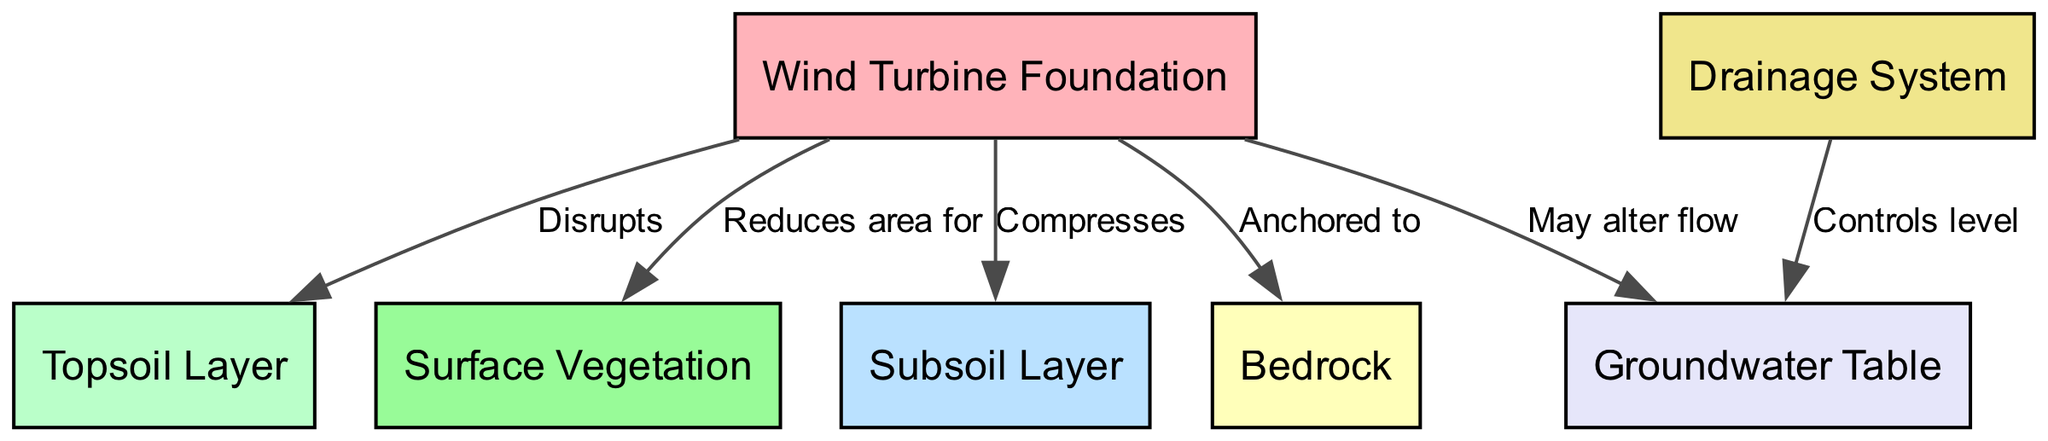What is the top layer above the wind turbine foundation? The diagram shows several layers of soil and structures in relation to the wind turbine foundation. The node directly above the foundation is identified as the "Topsoil Layer."
Answer: Topsoil Layer How many layers of soil are indicated in the diagram? The diagram includes three distinct layers of soil: Topsoil Layer, Subsoil Layer, and Bedrock. By counting these nodes, we find there are three layers.
Answer: Three What does the wind turbine foundation disrupt? According to the edge leading from the foundation to the topsoil, it is labeled "Disrupts," indicating the relationship between these two elements. Therefore, the foundation disrupts the Topsoil Layer.
Answer: Topsoil Layer Which layer is compressed by the wind turbine foundation? The diagram shows a direct connection between the foundation and the Subsoil Layer labeled "Compresses." This indicates that the wind turbine foundation compresses the subsoil.
Answer: Subsoil Layer What effect does the wind turbine foundation have on groundwater flow? The edge from the foundation to the groundwater indicates "May alter flow." This shows that the foundation can potentially change the flow of groundwater in the area.
Answer: May alter flow How does the drainage system influence the groundwater table? The diagram depicts a connection from the drainage system to the groundwater table labeled "Controls level." This means that the drainage system affects or maintains the groundwater level.
Answer: Controls level Which element reduces the area for vegetation growth? The diagram illustrates that the wind turbine foundation has a direct relationship with vegetation, labeled "Reduces area for." Thus, the foundation is the element that reduces the area available for vegetation growth.
Answer: Wind Turbine Foundation What is the lowest layer depicted in this diagram? The diagram indicates several layers, with Bedrock being the deepest layer beneath all other elements. Therefore, the bottom-most layer is bedrock.
Answer: Bedrock How many edges are displayed in the diagram? The diagram contains edges representing relationships between the nodes. Counting the edges shown, we find there are six edges in total.
Answer: Six 